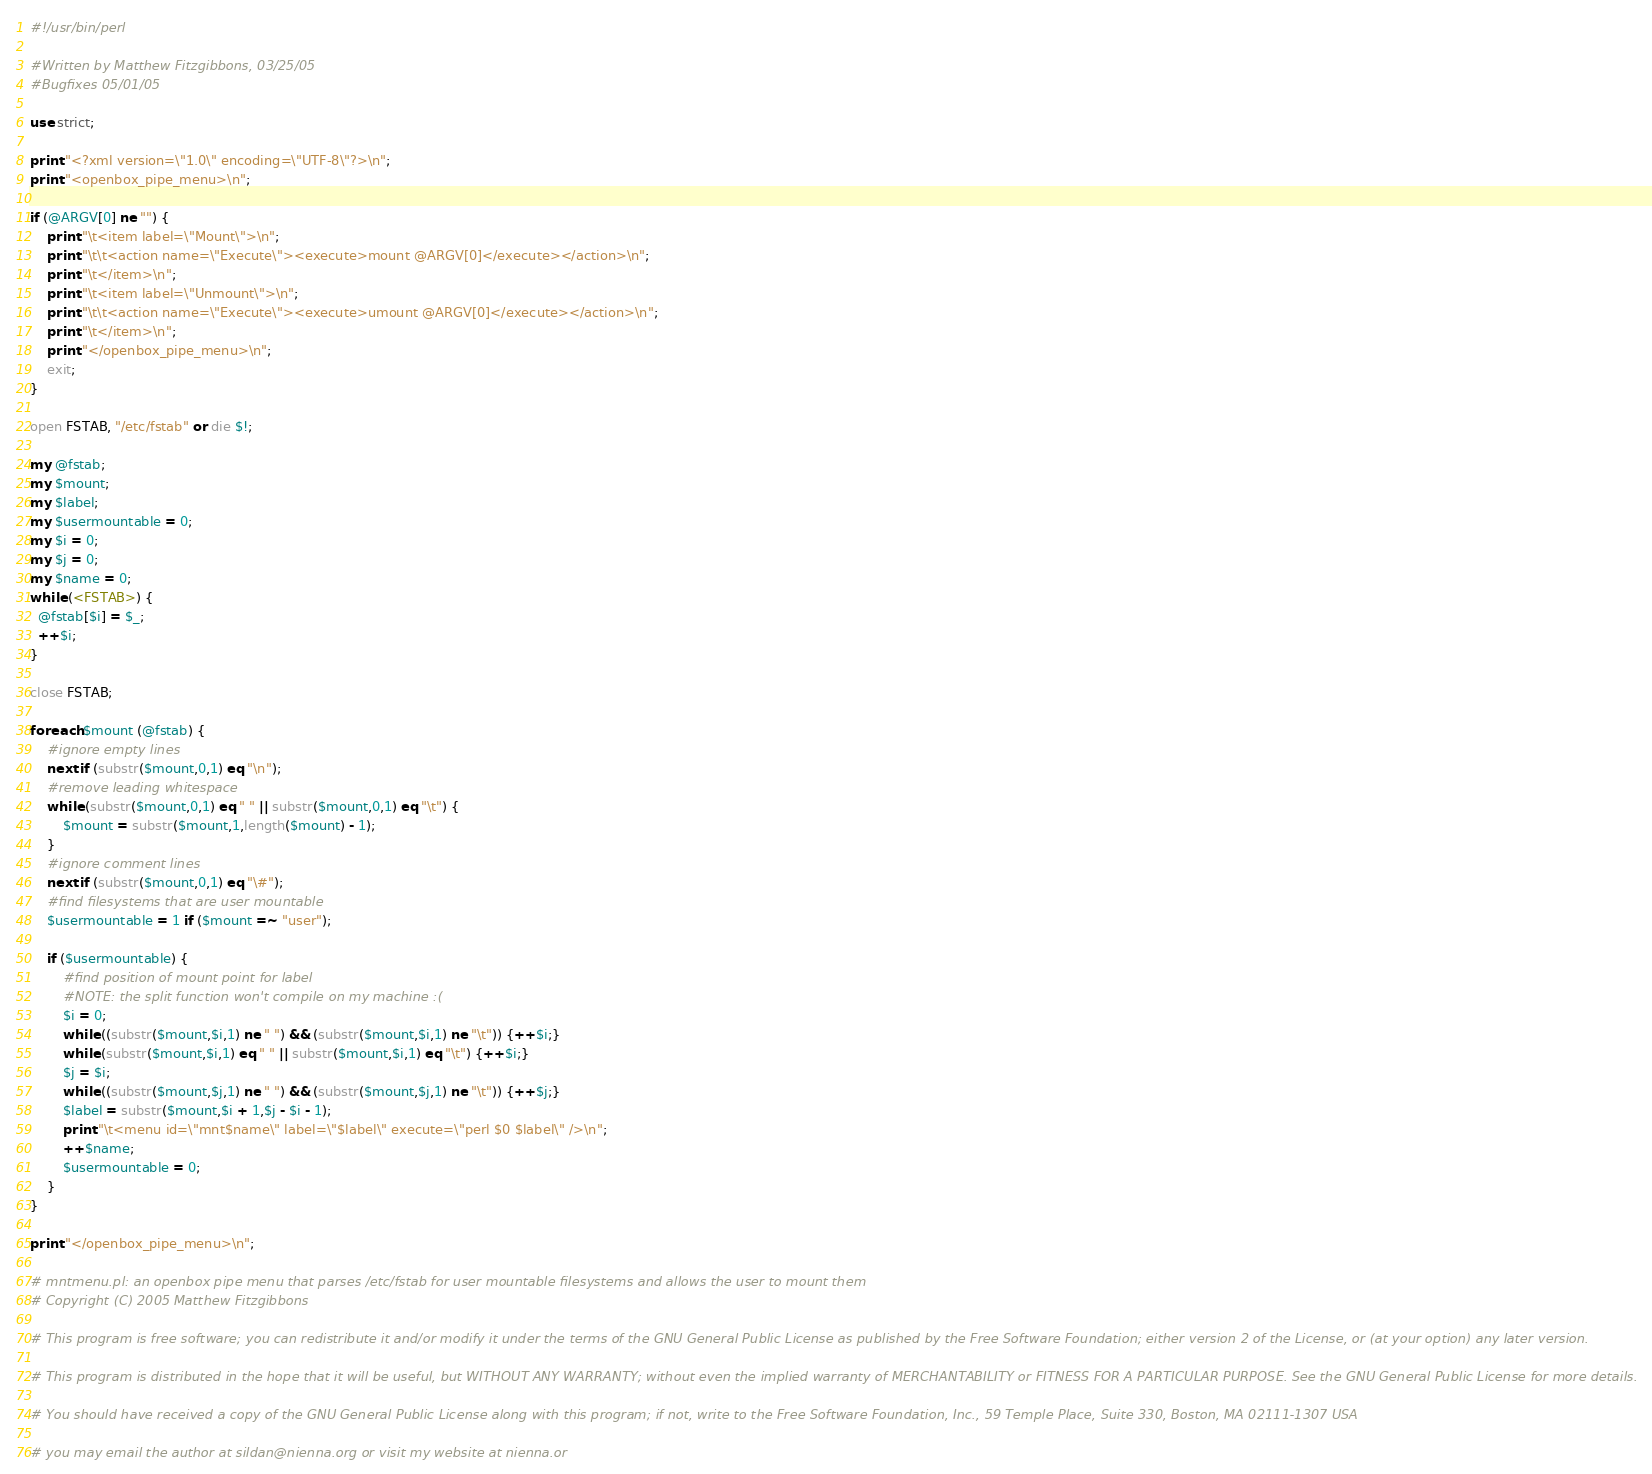Convert code to text. <code><loc_0><loc_0><loc_500><loc_500><_Perl_>#!/usr/bin/perl

#Written by Matthew Fitzgibbons, 03/25/05
#Bugfixes 05/01/05

use strict;

print "<?xml version=\"1.0\" encoding=\"UTF-8\"?>\n";
print "<openbox_pipe_menu>\n";

if (@ARGV[0] ne "") {
	print "\t<item label=\"Mount\">\n";
	print "\t\t<action name=\"Execute\"><execute>mount @ARGV[0]</execute></action>\n";
	print "\t</item>\n";
	print "\t<item label=\"Unmount\">\n";
	print "\t\t<action name=\"Execute\"><execute>umount @ARGV[0]</execute></action>\n";
	print "\t</item>\n";
	print "</openbox_pipe_menu>\n";
	exit;
}

open FSTAB, "/etc/fstab" or die $!;

my @fstab;
my $mount;
my $label;
my $usermountable = 0;
my $i = 0;
my $j = 0;
my $name = 0;
while (<FSTAB>) {
  @fstab[$i] = $_;
  ++$i;
}

close FSTAB;

foreach $mount (@fstab) {
	#ignore empty lines
	next if (substr($mount,0,1) eq "\n");
	#remove leading whitespace
	while (substr($mount,0,1) eq " " || substr($mount,0,1) eq "\t") {
		$mount = substr($mount,1,length($mount) - 1);
	}
	#ignore comment lines
	next if (substr($mount,0,1) eq "\#");
	#find filesystems that are user mountable
	$usermountable = 1 if ($mount =~ "user");

	if ($usermountable) {
		#find position of mount point for label
		#NOTE: the split function won't compile on my machine :(
		$i = 0;
		while ((substr($mount,$i,1) ne " ") && (substr($mount,$i,1) ne "\t")) {++$i;}
		while (substr($mount,$i,1) eq " " || substr($mount,$i,1) eq "\t") {++$i;}
		$j = $i;
		while ((substr($mount,$j,1) ne " ") && (substr($mount,$j,1) ne "\t")) {++$j;}
		$label = substr($mount,$i + 1,$j - $i - 1);
		print "\t<menu id=\"mnt$name\" label=\"$label\" execute=\"perl $0 $label\" />\n";
		++$name;
		$usermountable = 0;
	}
}

print "</openbox_pipe_menu>\n";

# mntmenu.pl: an openbox pipe menu that parses /etc/fstab for user mountable filesystems and allows the user to mount them
# Copyright (C) 2005 Matthew Fitzgibbons

# This program is free software; you can redistribute it and/or modify it under the terms of the GNU General Public License as published by the Free Software Foundation; either version 2 of the License, or (at your option) any later version.

# This program is distributed in the hope that it will be useful, but WITHOUT ANY WARRANTY; without even the implied warranty of MERCHANTABILITY or FITNESS FOR A PARTICULAR PURPOSE. See the GNU General Public License for more details.

# You should have received a copy of the GNU General Public License along with this program; if not, write to the Free Software Foundation, Inc., 59 Temple Place, Suite 330, Boston, MA 02111-1307 USA

# you may email the author at sildan@nienna.org or visit my website at nienna.or</code> 